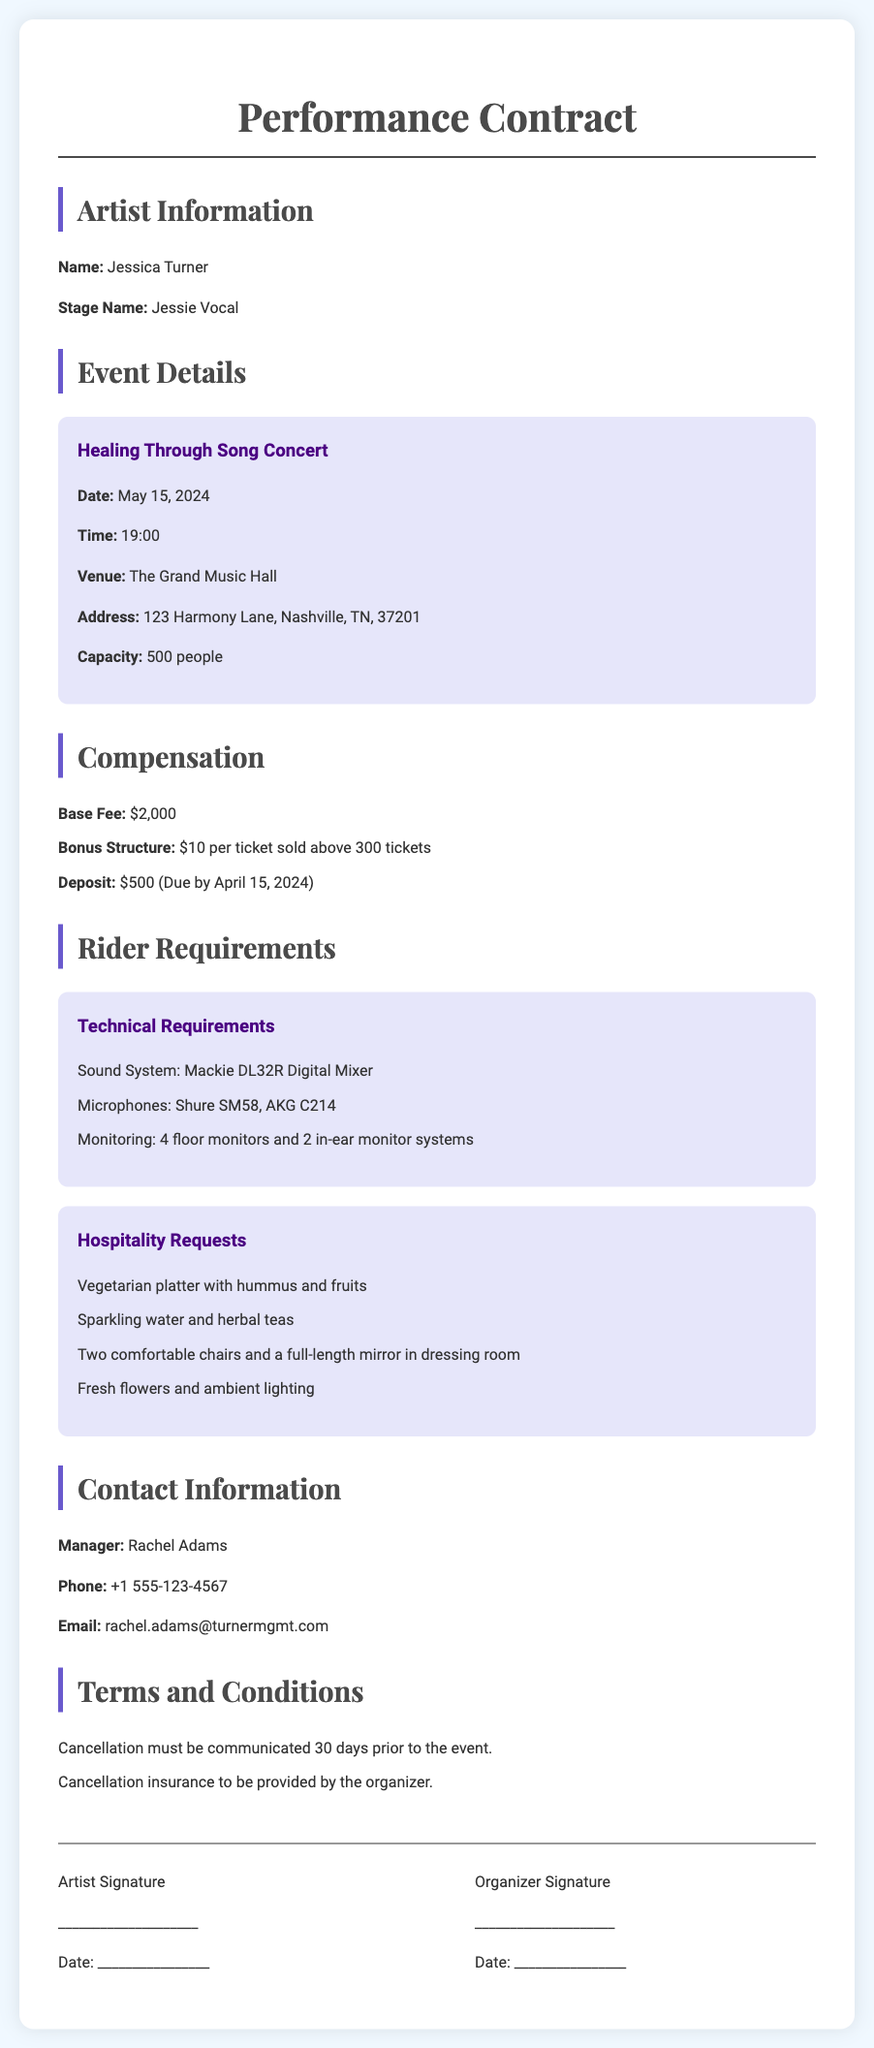What is the artist's stage name? The document provides the artist's stage name in the Artist Information section.
Answer: Jessie Vocal What is the date of the concert? The concert date is included in the Event Details section of the document.
Answer: May 15, 2024 What is the venue for the concert? The venue is mentioned in the Event Details section where the concert will take place.
Answer: The Grand Music Hall What is the base fee for the performance? The base fee is specified in the Compensation section of the document.
Answer: $2,000 What is the capacity of the venue? The venue capacity is listed under the Event Details section.
Answer: 500 people How much is the deposit required? The deposit amount is mentioned in the Compensation section.
Answer: $500 What is the bonus structure per ticket sold above 300? The bonus structure is outlined in the Compensation details.
Answer: $10 per ticket Which microphones are specified in the technical requirements? The specified microphones are listed under the Rider Requirements section.
Answer: Shure SM58, AKG C214 What cancellation notice period is required? The cancellation notice period is stated in the Terms and Conditions section.
Answer: 30 days 